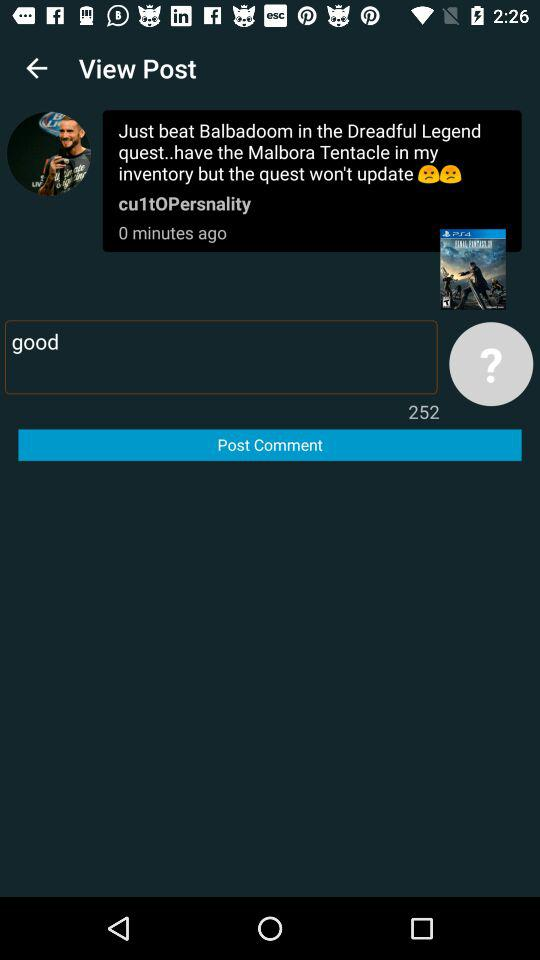How many minutes ago was the post published? The post was published 0 minutes ago. 